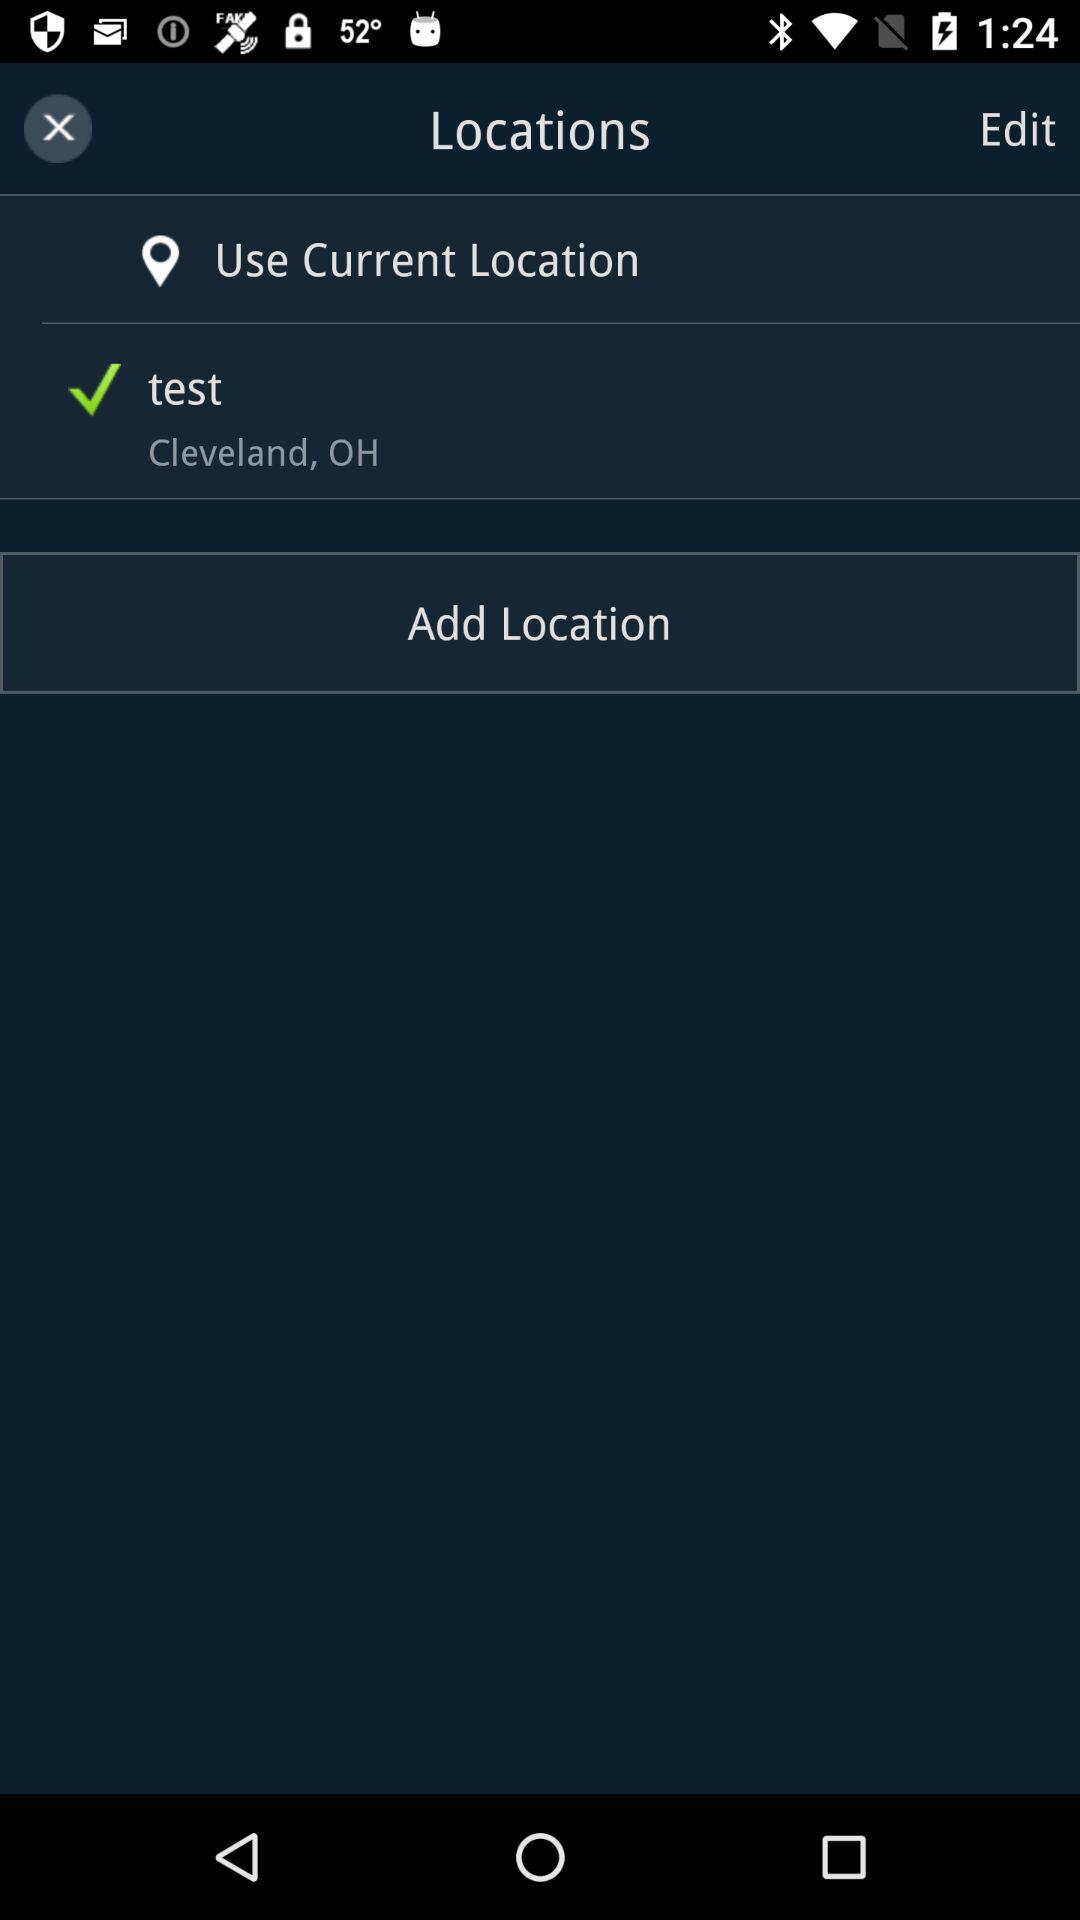What is the mentioned location? The mentioned location is Cleveland, OH. 